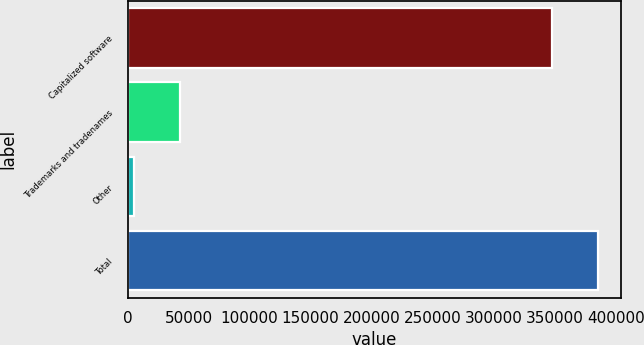Convert chart. <chart><loc_0><loc_0><loc_500><loc_500><bar_chart><fcel>Capitalized software<fcel>Trademarks and tradenames<fcel>Other<fcel>Total<nl><fcel>348022<fcel>42809.6<fcel>5614<fcel>385218<nl></chart> 